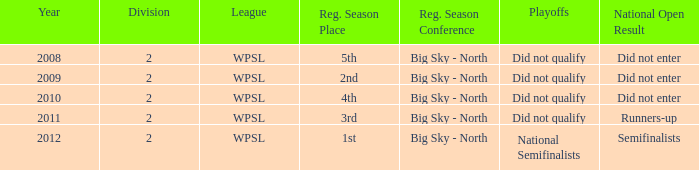What is the highest number of divisions mentioned? 2.0. 